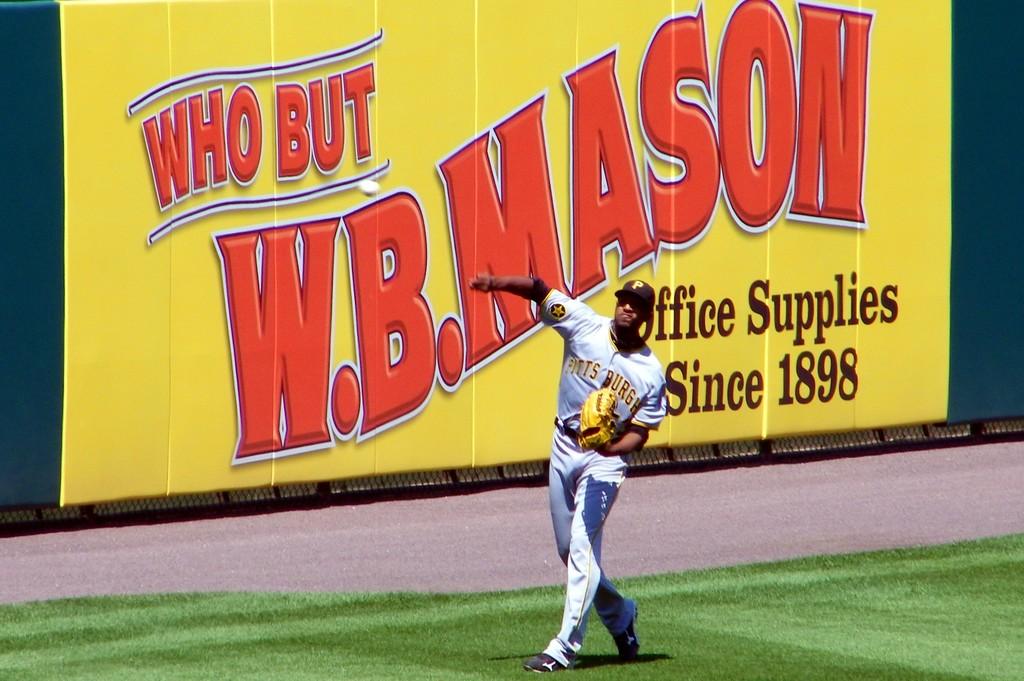What year was w.b. mason founded?
Your response must be concise. 1898. 